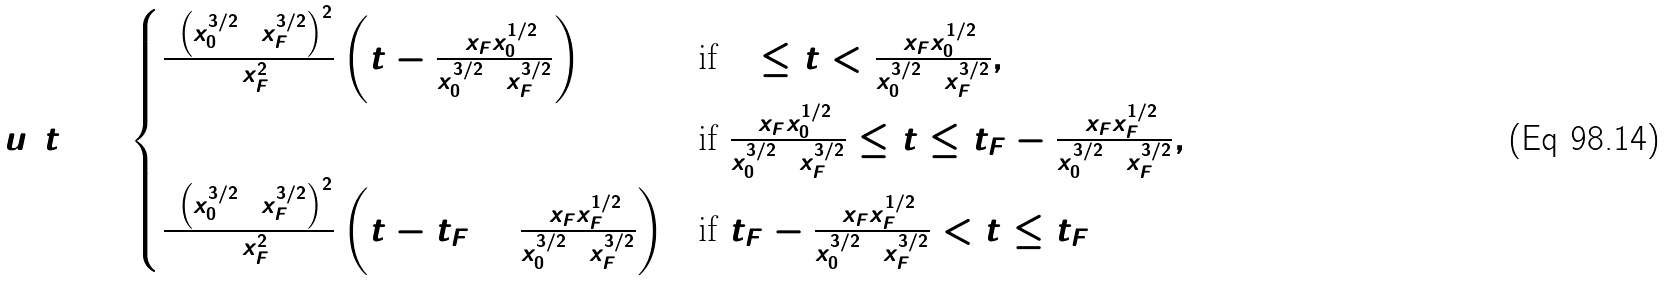Convert formula to latex. <formula><loc_0><loc_0><loc_500><loc_500>u ( t ) = \begin{cases} \frac { 2 \left ( \dot { x } _ { 0 } ^ { 3 / 2 } + \dot { x } _ { F } ^ { 3 / 2 } \right ) ^ { 2 } } { 9 x _ { F } ^ { 2 } } \left ( t - \frac { 3 x _ { F } \dot { x } _ { 0 } ^ { 1 / 2 } } { \dot { x } _ { 0 } ^ { 3 / 2 } + \dot { x } _ { F } ^ { 3 / 2 } } \right ) & \text {if } 0 \leq t < \frac { 3 x _ { F } \dot { x } _ { 0 } ^ { 1 / 2 } } { \dot { x } _ { 0 } ^ { 3 / 2 } + \dot { x } _ { F } ^ { 3 / 2 } } , \\ 0 & \text {if } \frac { 3 x _ { F } \dot { x } _ { 0 } ^ { 1 / 2 } } { \dot { x } _ { 0 } ^ { 3 / 2 } + \dot { x } _ { F } ^ { 3 / 2 } } \leq t \leq t _ { F } - \frac { 3 x _ { F } \dot { x } _ { F } ^ { 1 / 2 } } { \dot { x } _ { 0 } ^ { 3 / 2 } + \dot { x } _ { F } ^ { 3 / 2 } } , \\ \frac { 2 \left ( \dot { x } _ { 0 } ^ { 3 / 2 } + \dot { x } _ { F } ^ { 3 / 2 } \right ) ^ { 2 } } { 9 x _ { F } ^ { 2 } } \left ( t - t _ { F } + \frac { 3 x _ { F } \dot { x } _ { F } ^ { 1 / 2 } } { \dot { x } _ { 0 } ^ { 3 / 2 } + \dot { x } _ { F } ^ { 3 / 2 } } \right ) & \text {if } t _ { F } - \frac { 3 x _ { F } \dot { x } _ { F } ^ { 1 / 2 } } { \dot { x } _ { 0 } ^ { 3 / 2 } + \dot { x } _ { F } ^ { 3 / 2 } } < t \leq t _ { F } \end{cases}</formula> 